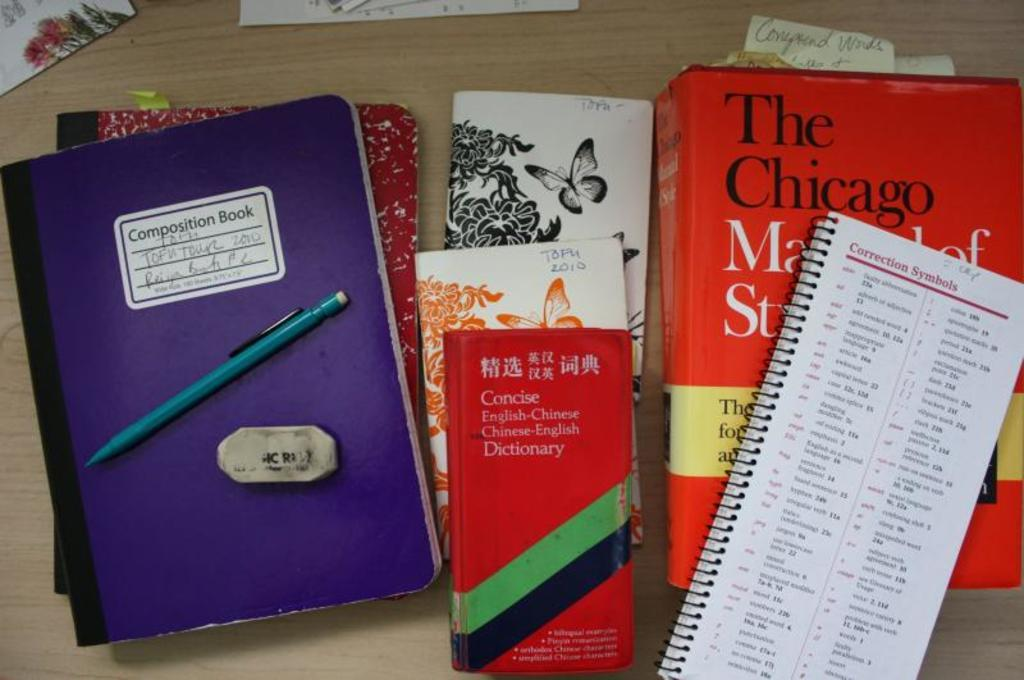Provide a one-sentence caption for the provided image. A composition book, an English-Chinese dictionary and some notebooks and text books placed on a wooden surface. 